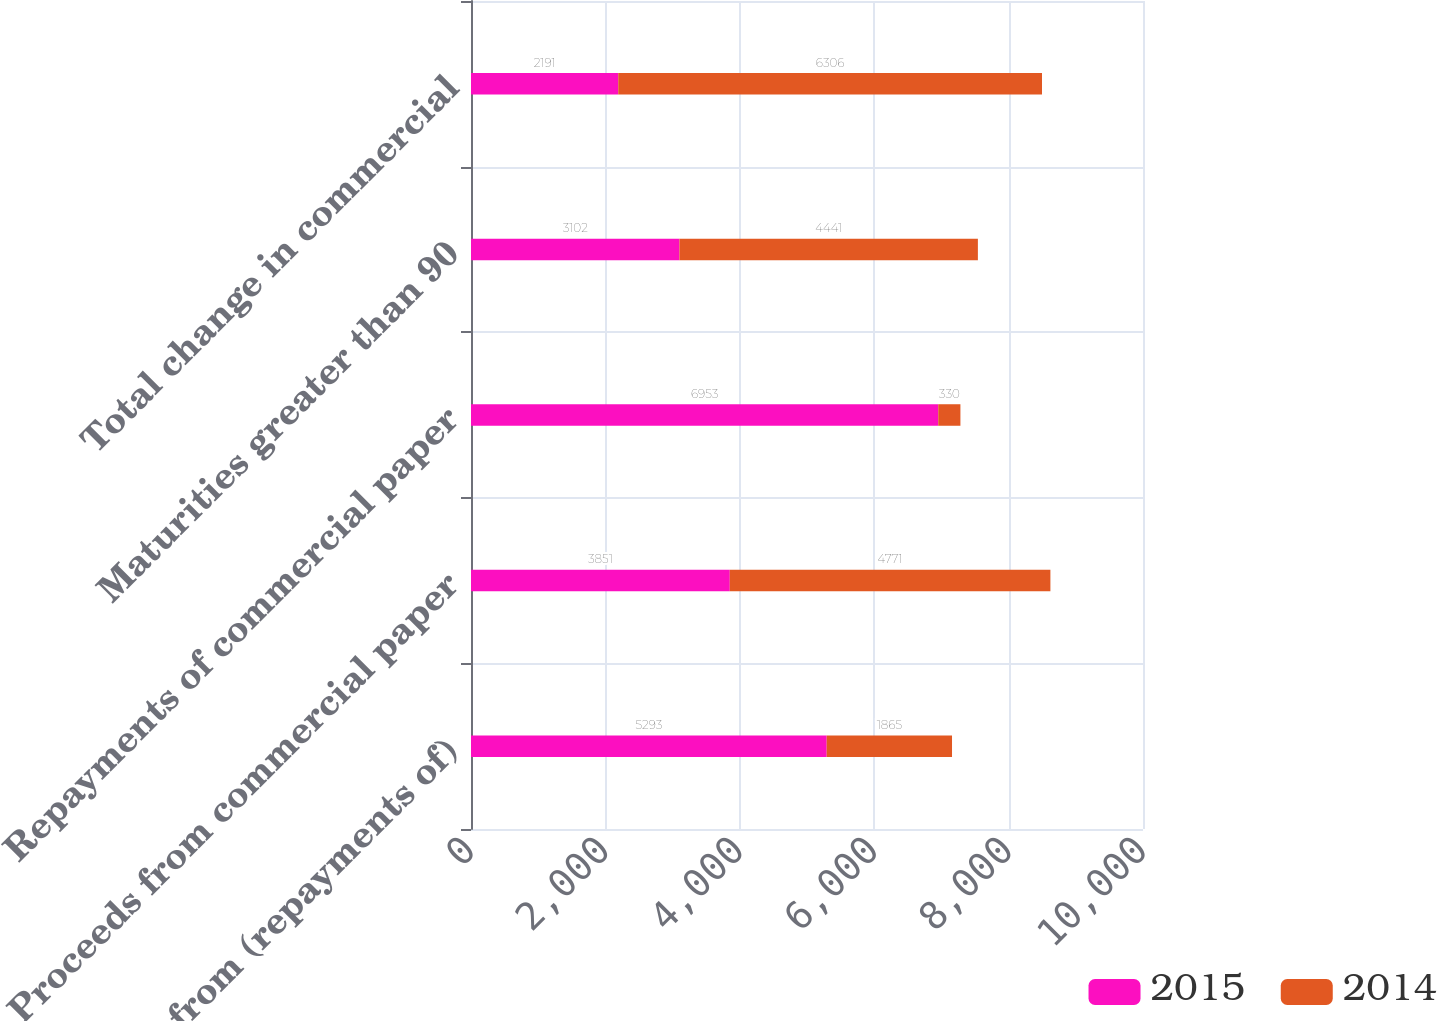Convert chart to OTSL. <chart><loc_0><loc_0><loc_500><loc_500><stacked_bar_chart><ecel><fcel>Proceeds from (repayments of)<fcel>Proceeds from commercial paper<fcel>Repayments of commercial paper<fcel>Maturities greater than 90<fcel>Total change in commercial<nl><fcel>2015<fcel>5293<fcel>3851<fcel>6953<fcel>3102<fcel>2191<nl><fcel>2014<fcel>1865<fcel>4771<fcel>330<fcel>4441<fcel>6306<nl></chart> 